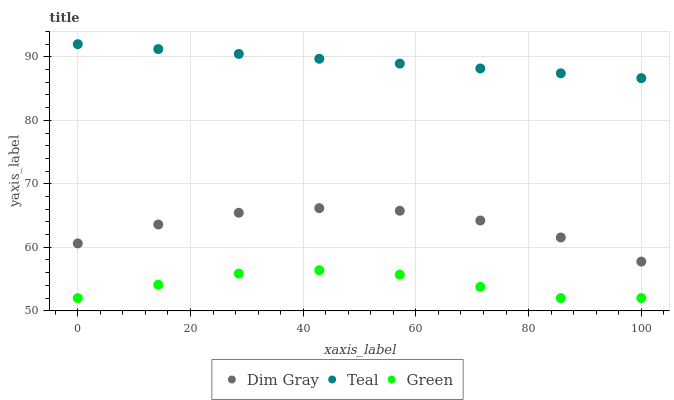Does Green have the minimum area under the curve?
Answer yes or no. Yes. Does Teal have the maximum area under the curve?
Answer yes or no. Yes. Does Teal have the minimum area under the curve?
Answer yes or no. No. Does Green have the maximum area under the curve?
Answer yes or no. No. Is Teal the smoothest?
Answer yes or no. Yes. Is Dim Gray the roughest?
Answer yes or no. Yes. Is Green the smoothest?
Answer yes or no. No. Is Green the roughest?
Answer yes or no. No. Does Green have the lowest value?
Answer yes or no. Yes. Does Teal have the lowest value?
Answer yes or no. No. Does Teal have the highest value?
Answer yes or no. Yes. Does Green have the highest value?
Answer yes or no. No. Is Green less than Dim Gray?
Answer yes or no. Yes. Is Dim Gray greater than Green?
Answer yes or no. Yes. Does Green intersect Dim Gray?
Answer yes or no. No. 